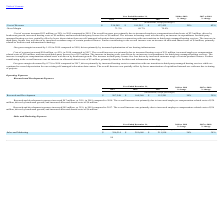According to Zendesk's financial document, How much was the increase in Research and Development expenses from 2018 to 2019? According to the financial document, $47 million. The relevant text states: "Research and development expenses increased $47 million, or 30%, in 2019 compared to 2018. The overall increase was primarily due to increased employee com..." Also, What are the primary components in the increase of Research and Development from 2017 to 2018?  The overall increase was primarily due to increased employee compensation-related costs of $36 million, driven by headcount growth, and increased allocated shared costs of $6 million.. The document states: "sed $45 million, or 39%, in 2018 compared to 2017. The overall increase was primarily due to increased employee compensation-related costs of $36 mill..." Also, can you calculate: What is the difference in the increase between Research and Development expenses from 2018 to 2019 and 2017 to 2018? Based on the calculation: $47 million - $45 million , the result is 2 (in millions). This is based on the information: "Research and development expenses increased $47 million, or 30%, in 2019 compared to 2018. The overall increase was primarily due to increased empl Research and development expenses increased $45 mill..." The key data points involved are: 45, 47. Also, What is the driver for an increase in employee compensation-related costs in 2019? driven by headcount growth. The document states: "crease in employee compensation-related costs was driven by headcount growth. The increase in third-party license fees was driven by increased custome..." Also, can you calculate: What is the percentage increase in Research and Development expense from 2017 to 2019? To answer this question, I need to perform calculations using the financial data. The calculation is: ((207,548 - 115,291)/115,291) , which equals 80.02 (percentage). This is based on the information: "Research and Development $ 207,548 $ 160,260 $ 115,291 30% 39% Research and Development $ 207,548 $ 160,260 $ 115,291 30% 39%..." The key data points involved are: 115,291, 207,548. Also, can you calculate: What is the total increase in allocated shared costs from 2017 to 2019? Based on the calculation: 6 + 8 , the result is 14 (in millions). This is based on the information: "Year Ended December 31, 2018 to 2019 Gross Margin 71.3% 69.7% 70.4% Year Ended December 31, 2018 to 2019..." The key data points involved are: 6, 8. 